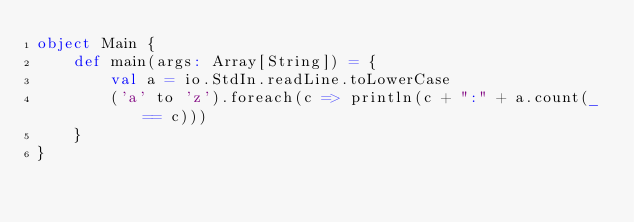<code> <loc_0><loc_0><loc_500><loc_500><_Scala_>object Main {
    def main(args: Array[String]) = {
        val a = io.StdIn.readLine.toLowerCase
        ('a' to 'z').foreach(c => println(c + ":" + a.count(_ == c)))
    }
}</code> 